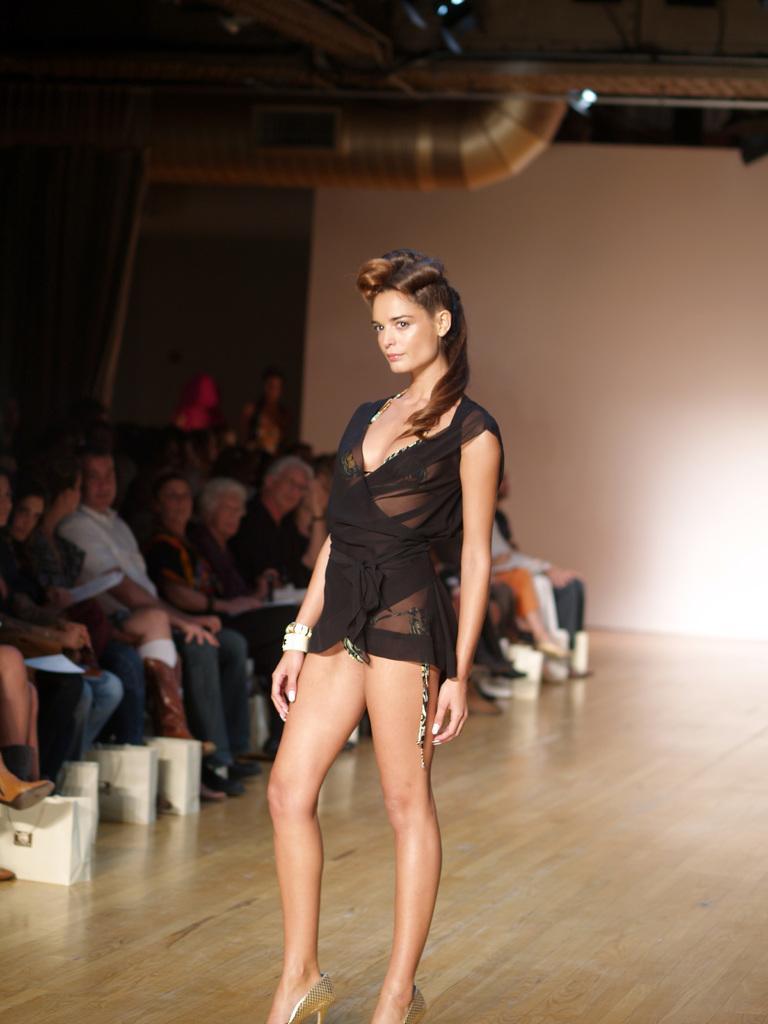Can you describe this image briefly? In this picture there is a girl standing on the floor and few people sitting. In the background of the image we can see wall. 